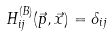<formula> <loc_0><loc_0><loc_500><loc_500>H _ { i j } ^ { ( B ) } ( \vec { p } , \vec { x } ) = \delta _ { i j }</formula> 